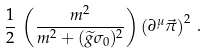Convert formula to latex. <formula><loc_0><loc_0><loc_500><loc_500>\frac { 1 } { 2 } \, \left ( \frac { m ^ { 2 } } { m ^ { 2 } + ( \widetilde { g } \sigma _ { 0 } ) ^ { 2 } } \right ) \left ( \partial ^ { \mu } \vec { \pi } \right ) ^ { 2 } \, .</formula> 